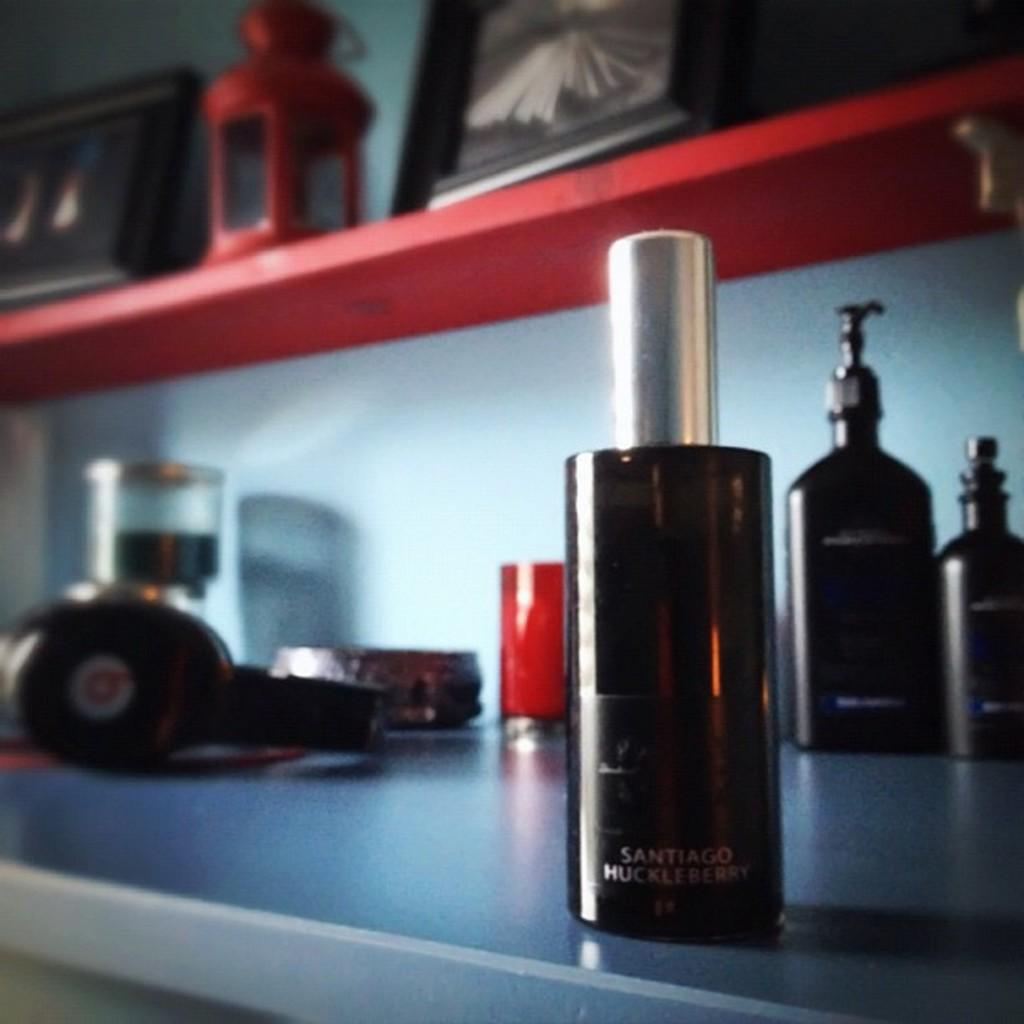<image>
Write a terse but informative summary of the picture. A bottle that says Santiago Huckleberry at the bottom. 